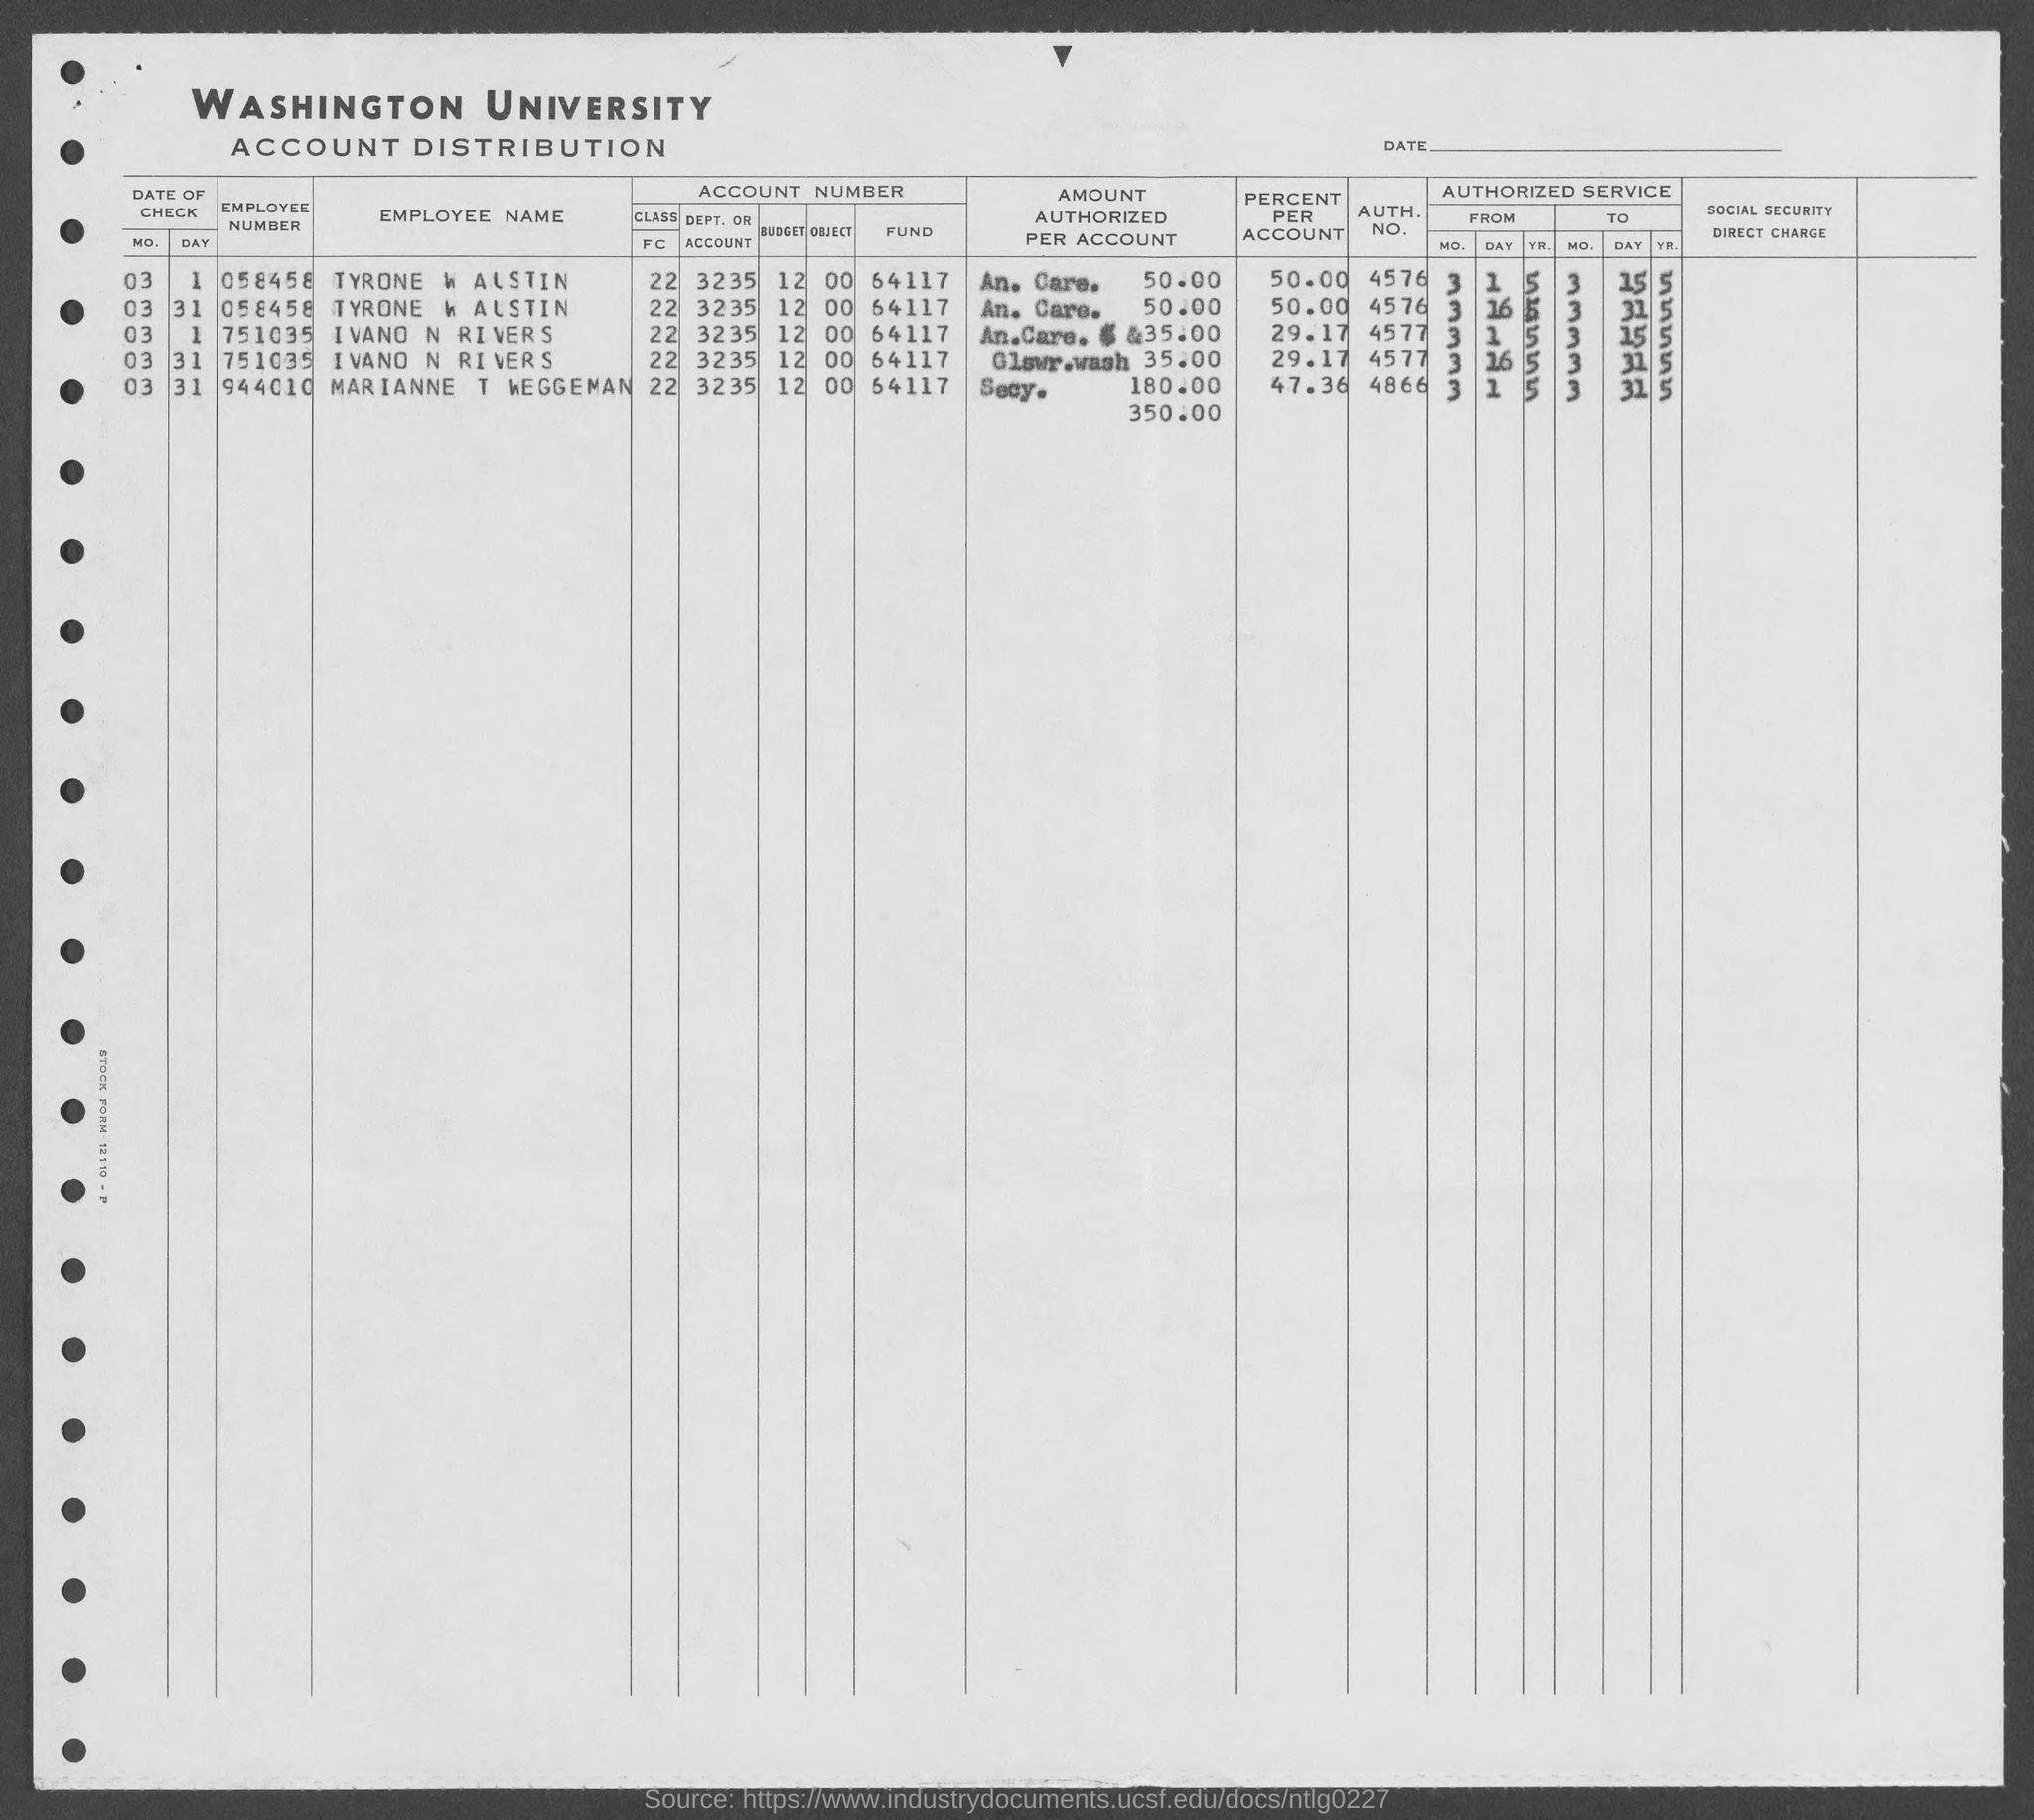Which is the Employee No of Tyrone W Austin?
Provide a succinct answer. 058458. Whose Employee No is 944010?
Make the answer very short. Marianne T Weggeman. Which University Account distribution is provided?
Keep it short and to the point. WASHINGTON. 